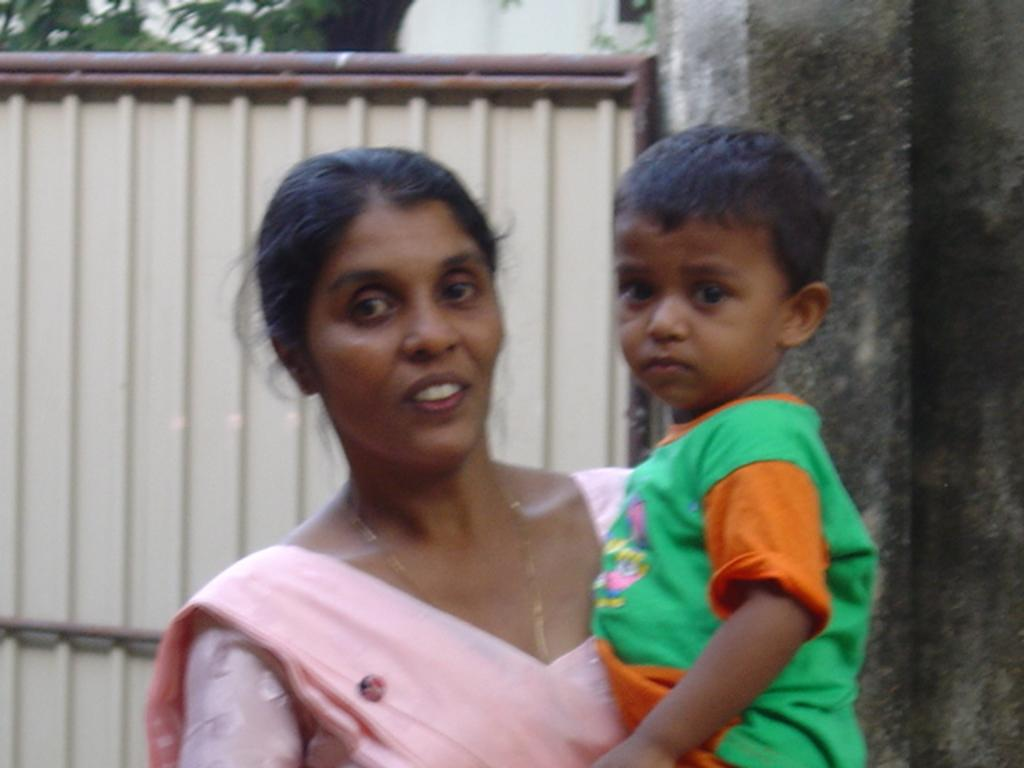Who is the main subject in the image? There is a lady standing in the center of the image. What is the lady doing in the image? The lady is holding a kid. What can be seen in the background of the image? There is a wall and a gate in the background of the image. What type of vegetation is visible at the top of the image? Trees are visible at the top of the image. What page of the book is the lady reading to the kid in the image? There is no book present in the image, so the lady is not reading to the kid. What type of star can be seen in the image? There are no stars visible in the image; it is a lady holding a kid in front of a wall and a gate. 